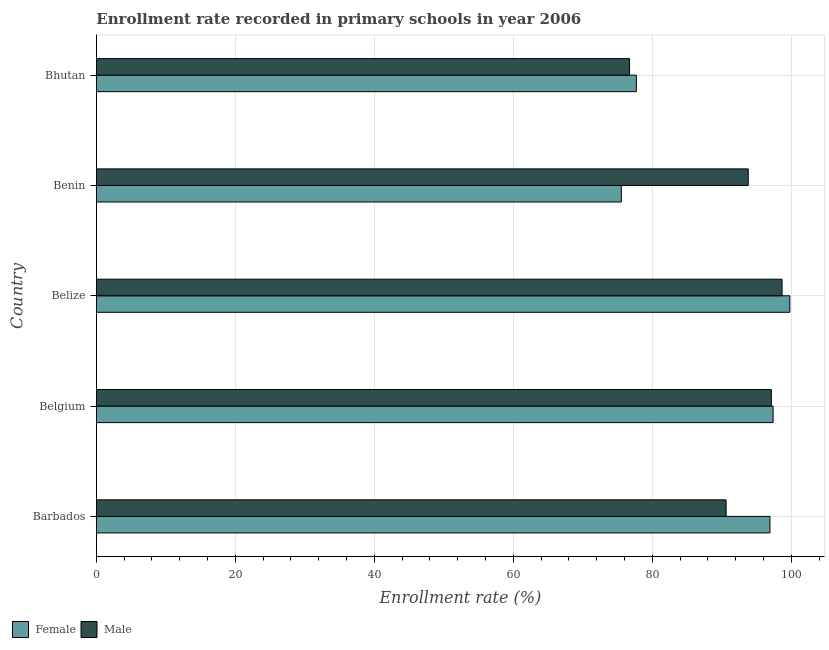How many groups of bars are there?
Your response must be concise. 5. Are the number of bars per tick equal to the number of legend labels?
Your answer should be very brief. Yes. How many bars are there on the 5th tick from the bottom?
Provide a short and direct response. 2. What is the label of the 1st group of bars from the top?
Give a very brief answer. Bhutan. In how many cases, is the number of bars for a given country not equal to the number of legend labels?
Offer a terse response. 0. What is the enrollment rate of female students in Belize?
Your answer should be compact. 99.78. Across all countries, what is the maximum enrollment rate of male students?
Your answer should be compact. 98.67. Across all countries, what is the minimum enrollment rate of female students?
Your response must be concise. 75.54. In which country was the enrollment rate of male students maximum?
Provide a succinct answer. Belize. In which country was the enrollment rate of male students minimum?
Ensure brevity in your answer.  Bhutan. What is the total enrollment rate of male students in the graph?
Offer a terse response. 456.92. What is the difference between the enrollment rate of female students in Belgium and that in Belize?
Offer a terse response. -2.4. What is the difference between the enrollment rate of female students in Belgium and the enrollment rate of male students in Belize?
Keep it short and to the point. -1.29. What is the average enrollment rate of female students per country?
Your response must be concise. 89.47. What is the difference between the enrollment rate of male students and enrollment rate of female students in Belize?
Provide a succinct answer. -1.12. In how many countries, is the enrollment rate of female students greater than 44 %?
Provide a short and direct response. 5. What is the ratio of the enrollment rate of female students in Benin to that in Bhutan?
Your response must be concise. 0.97. What is the difference between the highest and the second highest enrollment rate of male students?
Give a very brief answer. 1.54. What is the difference between the highest and the lowest enrollment rate of female students?
Offer a terse response. 24.24. Is the sum of the enrollment rate of female students in Belgium and Belize greater than the maximum enrollment rate of male students across all countries?
Offer a terse response. Yes. What does the 2nd bar from the top in Belize represents?
Provide a succinct answer. Female. How many bars are there?
Offer a terse response. 10. Does the graph contain grids?
Ensure brevity in your answer.  Yes. What is the title of the graph?
Keep it short and to the point. Enrollment rate recorded in primary schools in year 2006. What is the label or title of the X-axis?
Ensure brevity in your answer.  Enrollment rate (%). What is the Enrollment rate (%) in Female in Barbados?
Offer a terse response. 96.92. What is the Enrollment rate (%) of Male in Barbados?
Offer a terse response. 90.62. What is the Enrollment rate (%) in Female in Belgium?
Your answer should be very brief. 97.38. What is the Enrollment rate (%) of Male in Belgium?
Your response must be concise. 97.12. What is the Enrollment rate (%) of Female in Belize?
Make the answer very short. 99.78. What is the Enrollment rate (%) of Male in Belize?
Provide a short and direct response. 98.67. What is the Enrollment rate (%) of Female in Benin?
Provide a succinct answer. 75.54. What is the Enrollment rate (%) in Male in Benin?
Your response must be concise. 93.8. What is the Enrollment rate (%) of Female in Bhutan?
Give a very brief answer. 77.7. What is the Enrollment rate (%) of Male in Bhutan?
Give a very brief answer. 76.72. Across all countries, what is the maximum Enrollment rate (%) in Female?
Ensure brevity in your answer.  99.78. Across all countries, what is the maximum Enrollment rate (%) of Male?
Give a very brief answer. 98.67. Across all countries, what is the minimum Enrollment rate (%) of Female?
Provide a succinct answer. 75.54. Across all countries, what is the minimum Enrollment rate (%) in Male?
Keep it short and to the point. 76.72. What is the total Enrollment rate (%) of Female in the graph?
Give a very brief answer. 447.32. What is the total Enrollment rate (%) in Male in the graph?
Give a very brief answer. 456.92. What is the difference between the Enrollment rate (%) in Female in Barbados and that in Belgium?
Keep it short and to the point. -0.45. What is the difference between the Enrollment rate (%) of Male in Barbados and that in Belgium?
Your response must be concise. -6.51. What is the difference between the Enrollment rate (%) of Female in Barbados and that in Belize?
Your response must be concise. -2.86. What is the difference between the Enrollment rate (%) of Male in Barbados and that in Belize?
Provide a succinct answer. -8.05. What is the difference between the Enrollment rate (%) in Female in Barbados and that in Benin?
Provide a succinct answer. 21.38. What is the difference between the Enrollment rate (%) of Male in Barbados and that in Benin?
Provide a succinct answer. -3.18. What is the difference between the Enrollment rate (%) of Female in Barbados and that in Bhutan?
Your answer should be compact. 19.22. What is the difference between the Enrollment rate (%) of Male in Barbados and that in Bhutan?
Offer a terse response. 13.9. What is the difference between the Enrollment rate (%) of Female in Belgium and that in Belize?
Ensure brevity in your answer.  -2.4. What is the difference between the Enrollment rate (%) in Male in Belgium and that in Belize?
Provide a short and direct response. -1.54. What is the difference between the Enrollment rate (%) of Female in Belgium and that in Benin?
Provide a succinct answer. 21.84. What is the difference between the Enrollment rate (%) of Male in Belgium and that in Benin?
Keep it short and to the point. 3.32. What is the difference between the Enrollment rate (%) of Female in Belgium and that in Bhutan?
Ensure brevity in your answer.  19.68. What is the difference between the Enrollment rate (%) in Male in Belgium and that in Bhutan?
Ensure brevity in your answer.  20.4. What is the difference between the Enrollment rate (%) in Female in Belize and that in Benin?
Keep it short and to the point. 24.24. What is the difference between the Enrollment rate (%) of Male in Belize and that in Benin?
Give a very brief answer. 4.87. What is the difference between the Enrollment rate (%) of Female in Belize and that in Bhutan?
Give a very brief answer. 22.08. What is the difference between the Enrollment rate (%) of Male in Belize and that in Bhutan?
Your answer should be very brief. 21.95. What is the difference between the Enrollment rate (%) of Female in Benin and that in Bhutan?
Your answer should be very brief. -2.16. What is the difference between the Enrollment rate (%) of Male in Benin and that in Bhutan?
Ensure brevity in your answer.  17.08. What is the difference between the Enrollment rate (%) of Female in Barbados and the Enrollment rate (%) of Male in Belgium?
Offer a terse response. -0.2. What is the difference between the Enrollment rate (%) in Female in Barbados and the Enrollment rate (%) in Male in Belize?
Provide a short and direct response. -1.74. What is the difference between the Enrollment rate (%) in Female in Barbados and the Enrollment rate (%) in Male in Benin?
Offer a very short reply. 3.12. What is the difference between the Enrollment rate (%) in Female in Barbados and the Enrollment rate (%) in Male in Bhutan?
Offer a very short reply. 20.21. What is the difference between the Enrollment rate (%) of Female in Belgium and the Enrollment rate (%) of Male in Belize?
Ensure brevity in your answer.  -1.29. What is the difference between the Enrollment rate (%) of Female in Belgium and the Enrollment rate (%) of Male in Benin?
Make the answer very short. 3.58. What is the difference between the Enrollment rate (%) of Female in Belgium and the Enrollment rate (%) of Male in Bhutan?
Provide a short and direct response. 20.66. What is the difference between the Enrollment rate (%) in Female in Belize and the Enrollment rate (%) in Male in Benin?
Offer a very short reply. 5.98. What is the difference between the Enrollment rate (%) in Female in Belize and the Enrollment rate (%) in Male in Bhutan?
Make the answer very short. 23.06. What is the difference between the Enrollment rate (%) in Female in Benin and the Enrollment rate (%) in Male in Bhutan?
Provide a short and direct response. -1.18. What is the average Enrollment rate (%) of Female per country?
Make the answer very short. 89.46. What is the average Enrollment rate (%) in Male per country?
Ensure brevity in your answer.  91.38. What is the difference between the Enrollment rate (%) in Female and Enrollment rate (%) in Male in Barbados?
Your answer should be very brief. 6.31. What is the difference between the Enrollment rate (%) of Female and Enrollment rate (%) of Male in Belgium?
Provide a short and direct response. 0.26. What is the difference between the Enrollment rate (%) in Female and Enrollment rate (%) in Male in Belize?
Your answer should be compact. 1.12. What is the difference between the Enrollment rate (%) in Female and Enrollment rate (%) in Male in Benin?
Offer a very short reply. -18.26. What is the difference between the Enrollment rate (%) in Female and Enrollment rate (%) in Male in Bhutan?
Offer a very short reply. 0.98. What is the ratio of the Enrollment rate (%) of Male in Barbados to that in Belgium?
Make the answer very short. 0.93. What is the ratio of the Enrollment rate (%) of Female in Barbados to that in Belize?
Your answer should be very brief. 0.97. What is the ratio of the Enrollment rate (%) in Male in Barbados to that in Belize?
Make the answer very short. 0.92. What is the ratio of the Enrollment rate (%) of Female in Barbados to that in Benin?
Make the answer very short. 1.28. What is the ratio of the Enrollment rate (%) of Male in Barbados to that in Benin?
Your response must be concise. 0.97. What is the ratio of the Enrollment rate (%) in Female in Barbados to that in Bhutan?
Offer a terse response. 1.25. What is the ratio of the Enrollment rate (%) of Male in Barbados to that in Bhutan?
Offer a terse response. 1.18. What is the ratio of the Enrollment rate (%) of Female in Belgium to that in Belize?
Offer a very short reply. 0.98. What is the ratio of the Enrollment rate (%) of Male in Belgium to that in Belize?
Keep it short and to the point. 0.98. What is the ratio of the Enrollment rate (%) of Female in Belgium to that in Benin?
Offer a terse response. 1.29. What is the ratio of the Enrollment rate (%) of Male in Belgium to that in Benin?
Offer a terse response. 1.04. What is the ratio of the Enrollment rate (%) of Female in Belgium to that in Bhutan?
Your answer should be compact. 1.25. What is the ratio of the Enrollment rate (%) of Male in Belgium to that in Bhutan?
Your answer should be very brief. 1.27. What is the ratio of the Enrollment rate (%) of Female in Belize to that in Benin?
Give a very brief answer. 1.32. What is the ratio of the Enrollment rate (%) of Male in Belize to that in Benin?
Offer a terse response. 1.05. What is the ratio of the Enrollment rate (%) in Female in Belize to that in Bhutan?
Give a very brief answer. 1.28. What is the ratio of the Enrollment rate (%) in Male in Belize to that in Bhutan?
Keep it short and to the point. 1.29. What is the ratio of the Enrollment rate (%) of Female in Benin to that in Bhutan?
Offer a terse response. 0.97. What is the ratio of the Enrollment rate (%) of Male in Benin to that in Bhutan?
Offer a terse response. 1.22. What is the difference between the highest and the second highest Enrollment rate (%) in Female?
Make the answer very short. 2.4. What is the difference between the highest and the second highest Enrollment rate (%) in Male?
Provide a short and direct response. 1.54. What is the difference between the highest and the lowest Enrollment rate (%) in Female?
Provide a succinct answer. 24.24. What is the difference between the highest and the lowest Enrollment rate (%) in Male?
Offer a terse response. 21.95. 